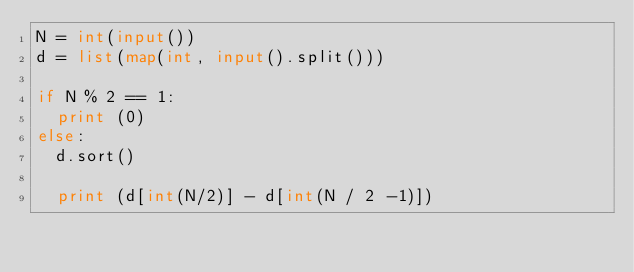Convert code to text. <code><loc_0><loc_0><loc_500><loc_500><_Python_>N = int(input())
d = list(map(int, input().split()))

if N % 2 == 1:
  print (0)
else:
  d.sort()

  print (d[int(N/2)] - d[int(N / 2 -1)])</code> 